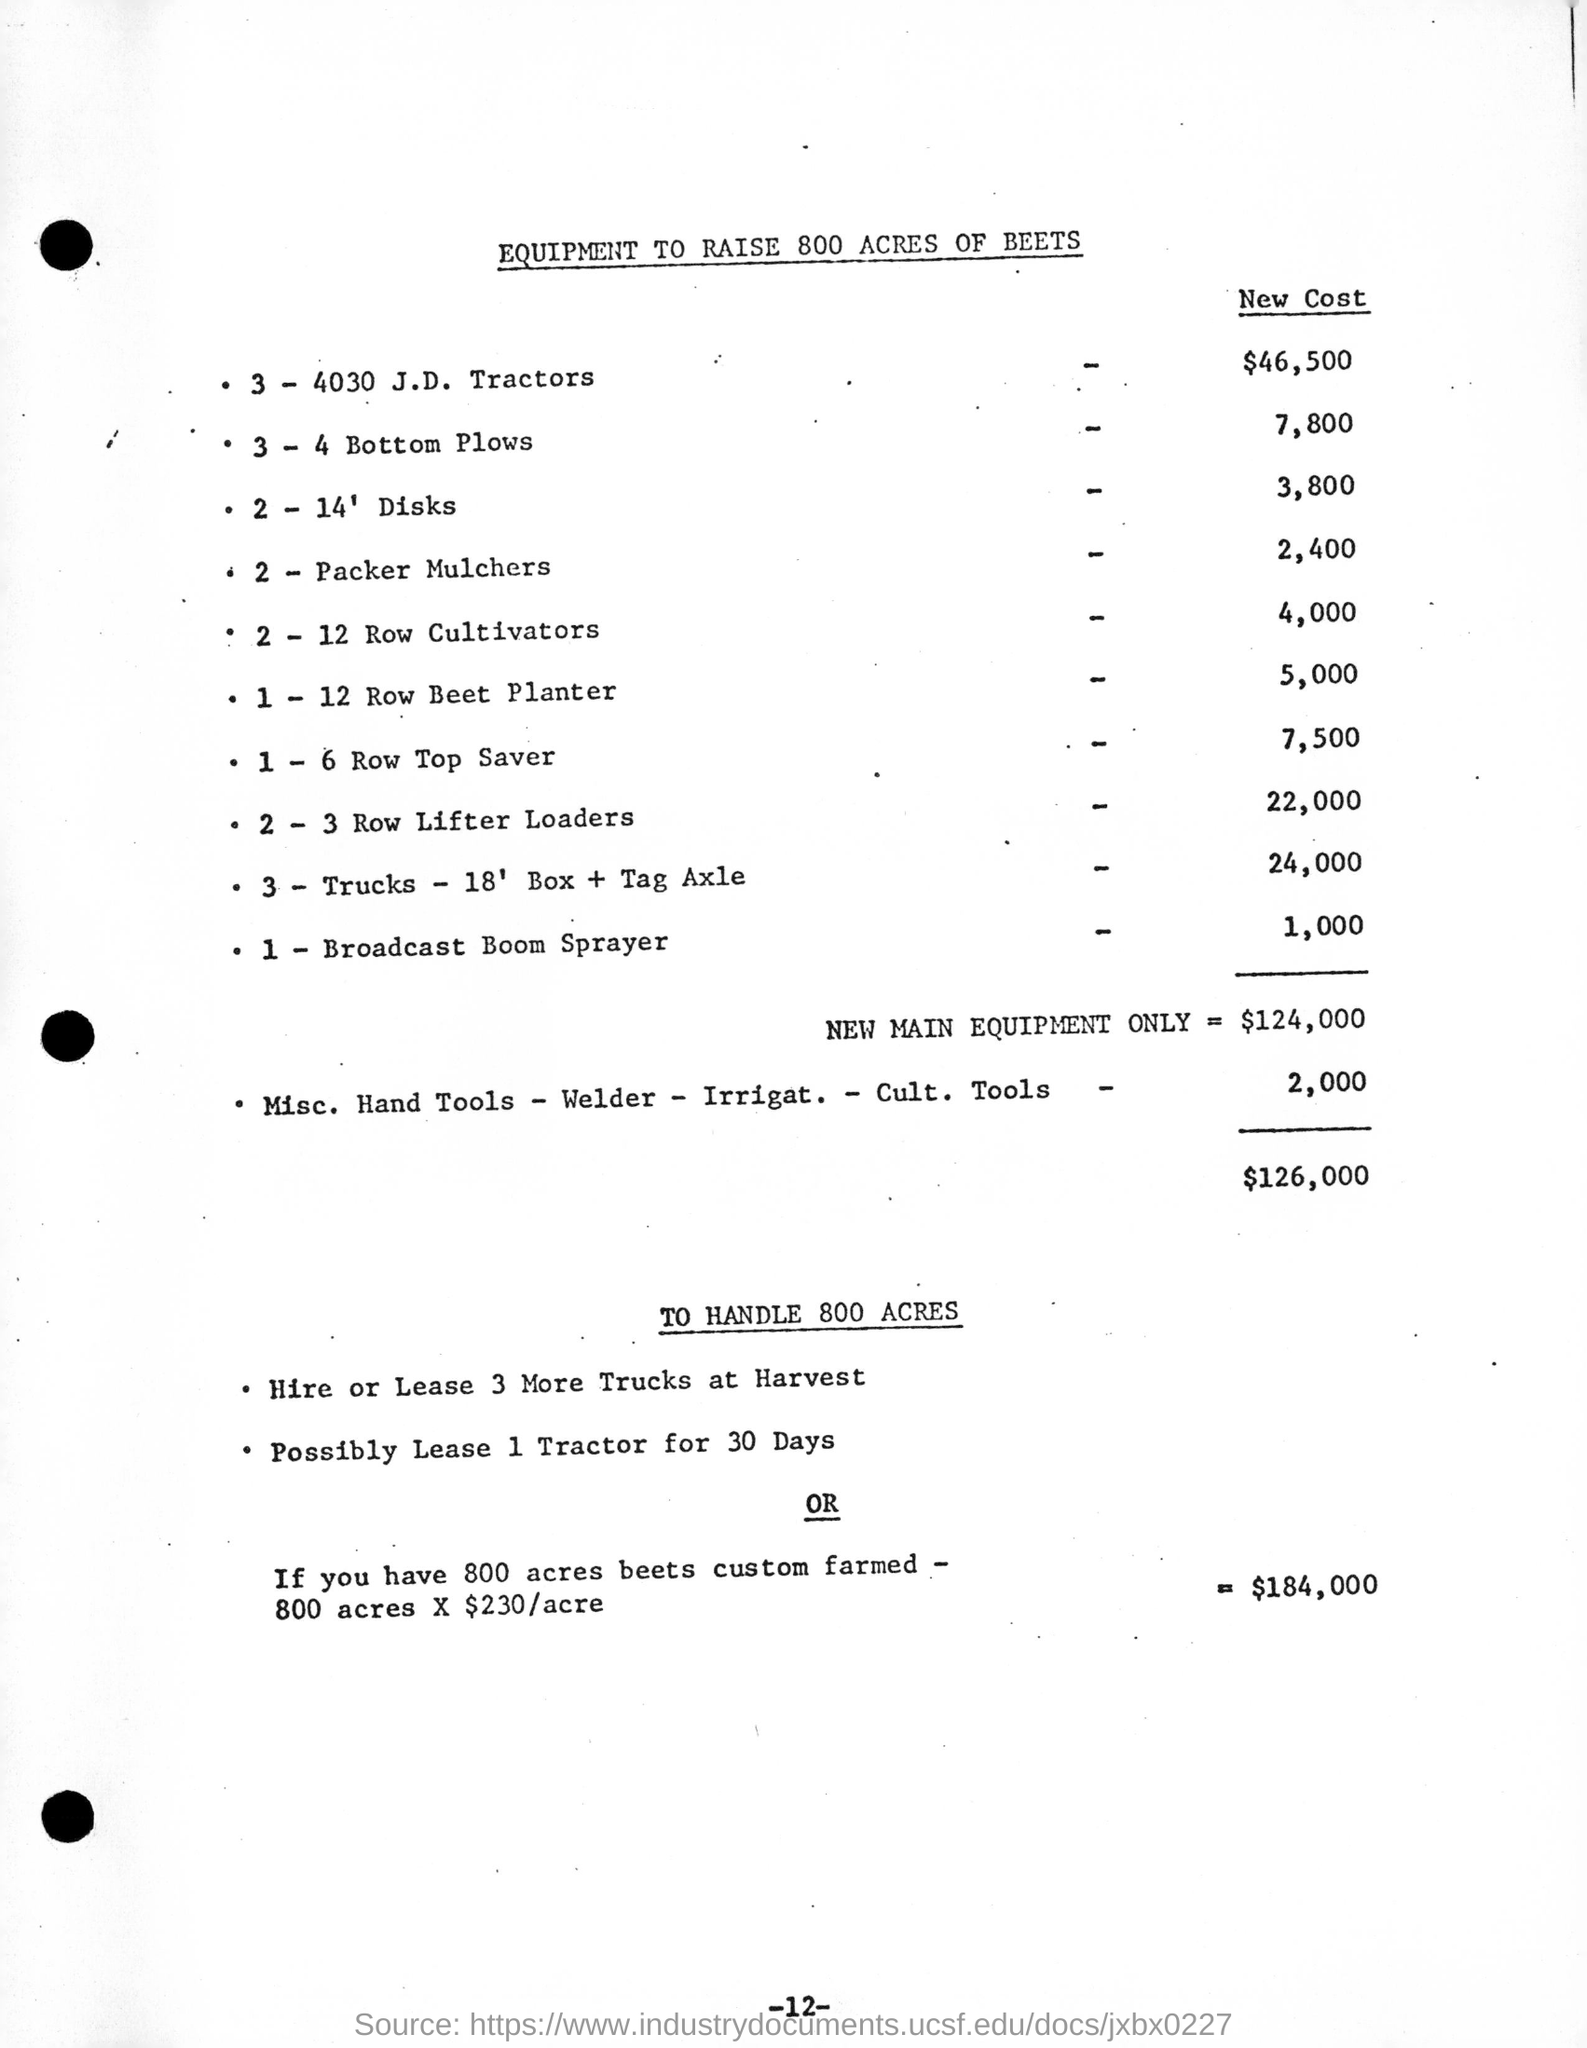Identify some key points in this picture. The cost of new main equipment only is estimated to be $124,000. The cost for a single broadcast boom sprayer is now 1000. It is possible that one tractor can be leased for 30 days. To effectively manage 800 acres, the number of additional trucks that need to be leased or hired will be 3. The cost of one 6-row top saver is 7,500. 